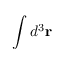<formula> <loc_0><loc_0><loc_500><loc_500>\int d ^ { 3 } r</formula> 